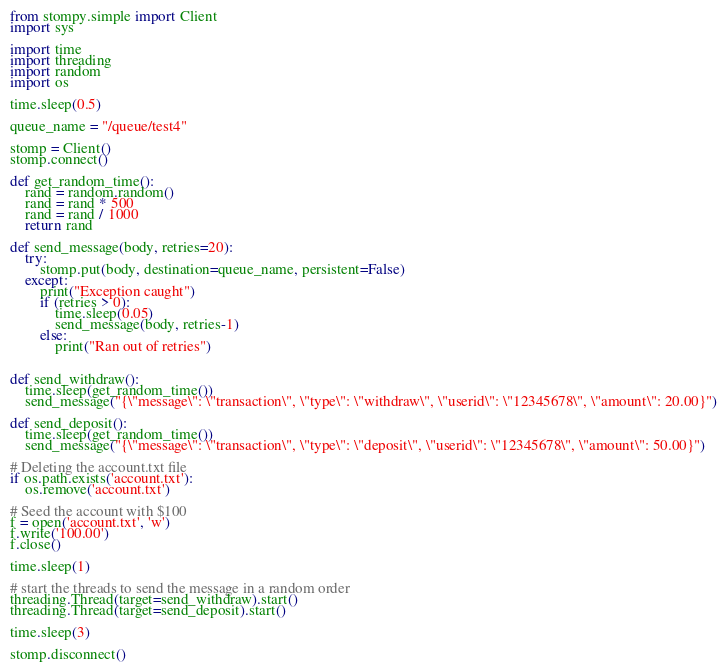Convert code to text. <code><loc_0><loc_0><loc_500><loc_500><_Python_>from stompy.simple import Client
import sys

import time
import threading
import random
import os

time.sleep(0.5)

queue_name = "/queue/test4"

stomp = Client()
stomp.connect()

def get_random_time():
	rand = random.random()
	rand = rand * 500
	rand = rand / 1000
	return rand

def send_message(body, retries=20):
	try:
		stomp.put(body, destination=queue_name, persistent=False)
	except:
		print("Exception caught")
		if (retries > 0):
			time.sleep(0.05)
			send_message(body, retries-1)
		else:
			print("Ran out of retries")


def send_withdraw():
	time.sleep(get_random_time())
	send_message("{\"message\": \"transaction\", \"type\": \"withdraw\", \"userid\": \"12345678\", \"amount\": 20.00}")

def send_deposit():
	time.sleep(get_random_time())
	send_message("{\"message\": \"transaction\", \"type\": \"deposit\", \"userid\": \"12345678\", \"amount\": 50.00}")

# Deleting the account.txt file
if os.path.exists('account.txt'):
	os.remove('account.txt')

# Seed the account with $100
f = open('account.txt', 'w')
f.write('100.00')
f.close()

time.sleep(1)

# start the threads to send the message in a random order
threading.Thread(target=send_withdraw).start()
threading.Thread(target=send_deposit).start()

time.sleep(3)

stomp.disconnect()
</code> 